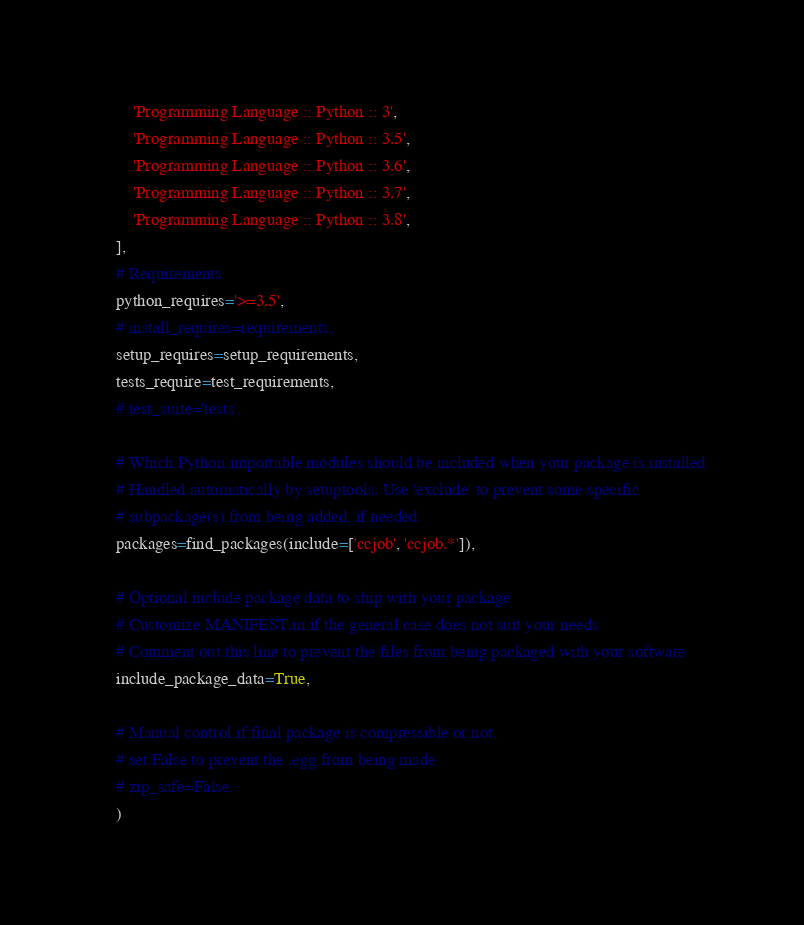Convert code to text. <code><loc_0><loc_0><loc_500><loc_500><_Python_>        'Programming Language :: Python :: 3',
        'Programming Language :: Python :: 3.5',
        'Programming Language :: Python :: 3.6',
        'Programming Language :: Python :: 3.7',
        'Programming Language :: Python :: 3.8',
    ],
    # Requirements
    python_requires='>=3.5',
    # install_requires=requirements,
    setup_requires=setup_requirements,
    tests_require=test_requirements,
    # test_suite='tests',

    # Which Python importable modules should be included when your package is installed
    # Handled automatically by setuptools. Use 'exclude' to prevent some specific
    # subpackage(s) from being added, if needed
    packages=find_packages(include=['ccjob', 'ccjob.*']),

    # Optional include package data to ship with your package
    # Customize MANIFEST.in if the general case does not suit your needs
    # Comment out this line to prevent the files from being packaged with your software
    include_package_data=True,

    # Manual control if final package is compressible or not,
    # set False to prevent the .egg from being made
    # zip_safe=False,
    )
</code> 